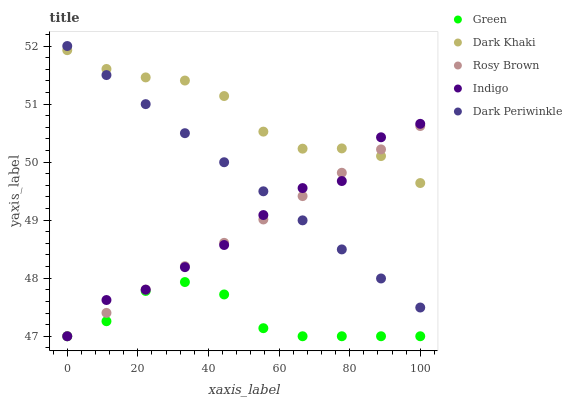Does Green have the minimum area under the curve?
Answer yes or no. Yes. Does Dark Khaki have the maximum area under the curve?
Answer yes or no. Yes. Does Indigo have the minimum area under the curve?
Answer yes or no. No. Does Indigo have the maximum area under the curve?
Answer yes or no. No. Is Rosy Brown the smoothest?
Answer yes or no. Yes. Is Indigo the roughest?
Answer yes or no. Yes. Is Indigo the smoothest?
Answer yes or no. No. Is Rosy Brown the roughest?
Answer yes or no. No. Does Indigo have the lowest value?
Answer yes or no. Yes. Does Dark Periwinkle have the lowest value?
Answer yes or no. No. Does Dark Periwinkle have the highest value?
Answer yes or no. Yes. Does Indigo have the highest value?
Answer yes or no. No. Is Green less than Dark Khaki?
Answer yes or no. Yes. Is Dark Khaki greater than Green?
Answer yes or no. Yes. Does Rosy Brown intersect Green?
Answer yes or no. Yes. Is Rosy Brown less than Green?
Answer yes or no. No. Is Rosy Brown greater than Green?
Answer yes or no. No. Does Green intersect Dark Khaki?
Answer yes or no. No. 